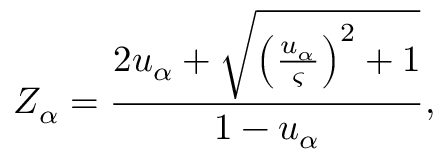Convert formula to latex. <formula><loc_0><loc_0><loc_500><loc_500>Z _ { \alpha } = \frac { 2 u _ { \alpha } + \sqrt { { \left ( \frac { u _ { \alpha } } { \varsigma } \right ) } ^ { 2 } + 1 } } { 1 - u _ { \alpha } } ,</formula> 